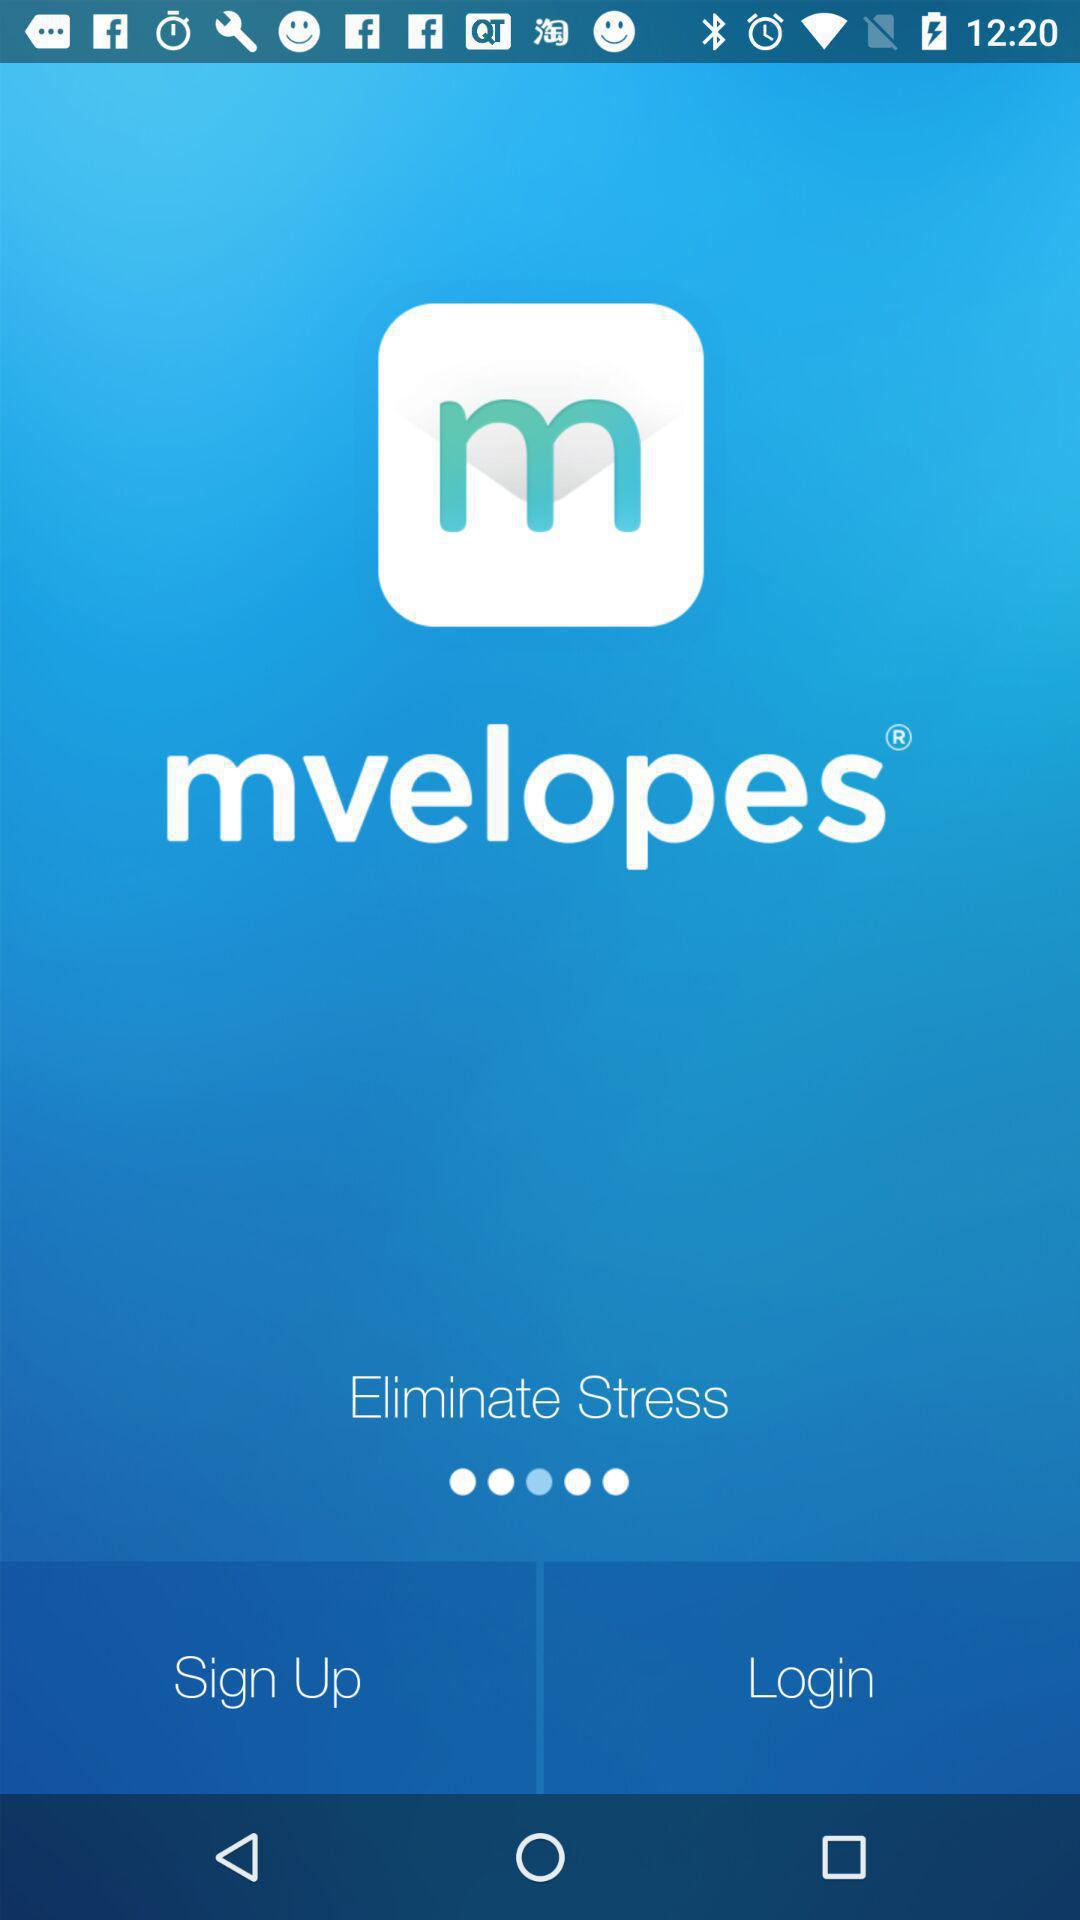What is the name of the application? The name of the application is "mvelopes". 